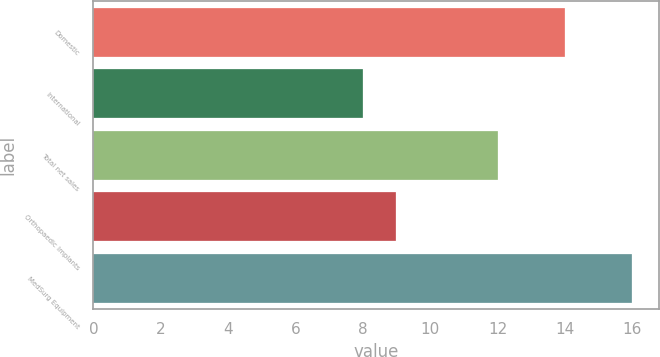Convert chart. <chart><loc_0><loc_0><loc_500><loc_500><bar_chart><fcel>Domestic<fcel>International<fcel>Total net sales<fcel>Orthopaedic Implants<fcel>MedSurg Equipment<nl><fcel>14<fcel>8<fcel>12<fcel>9<fcel>16<nl></chart> 